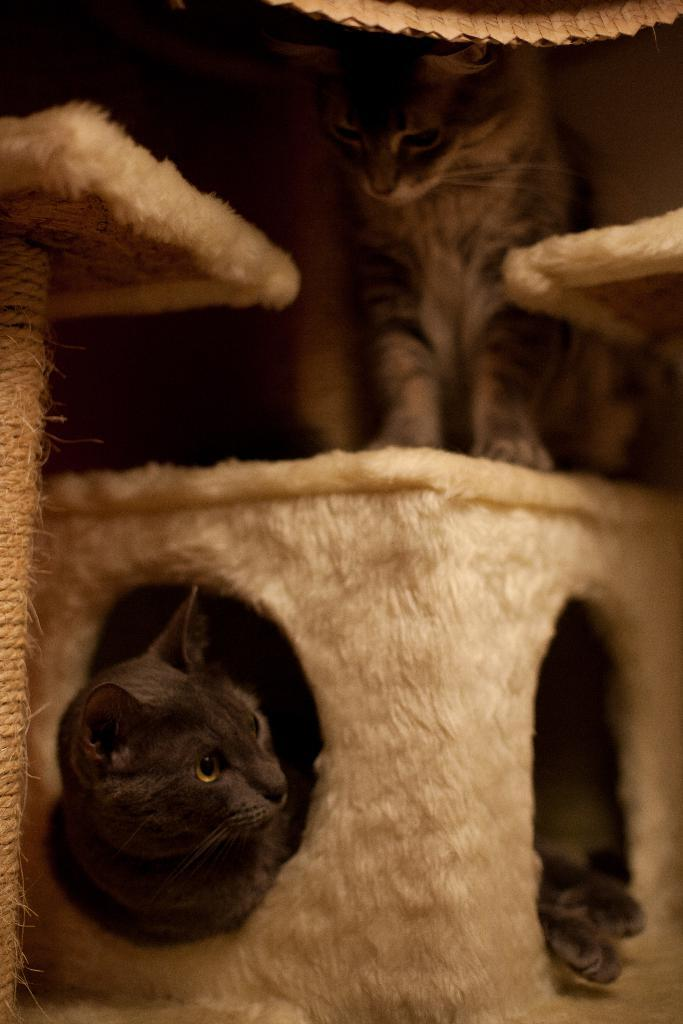What is in the basket in the image? There is a cat in the basket. Can you describe the position of the second cat in the image? There is another cat on the basket. What else can be seen around the basket in the image? There are other things around the basket. What religious beliefs are represented by the cat in the basket? The image does not depict any religious beliefs or symbols, and the cat in the basket is not associated with any specific religion. 